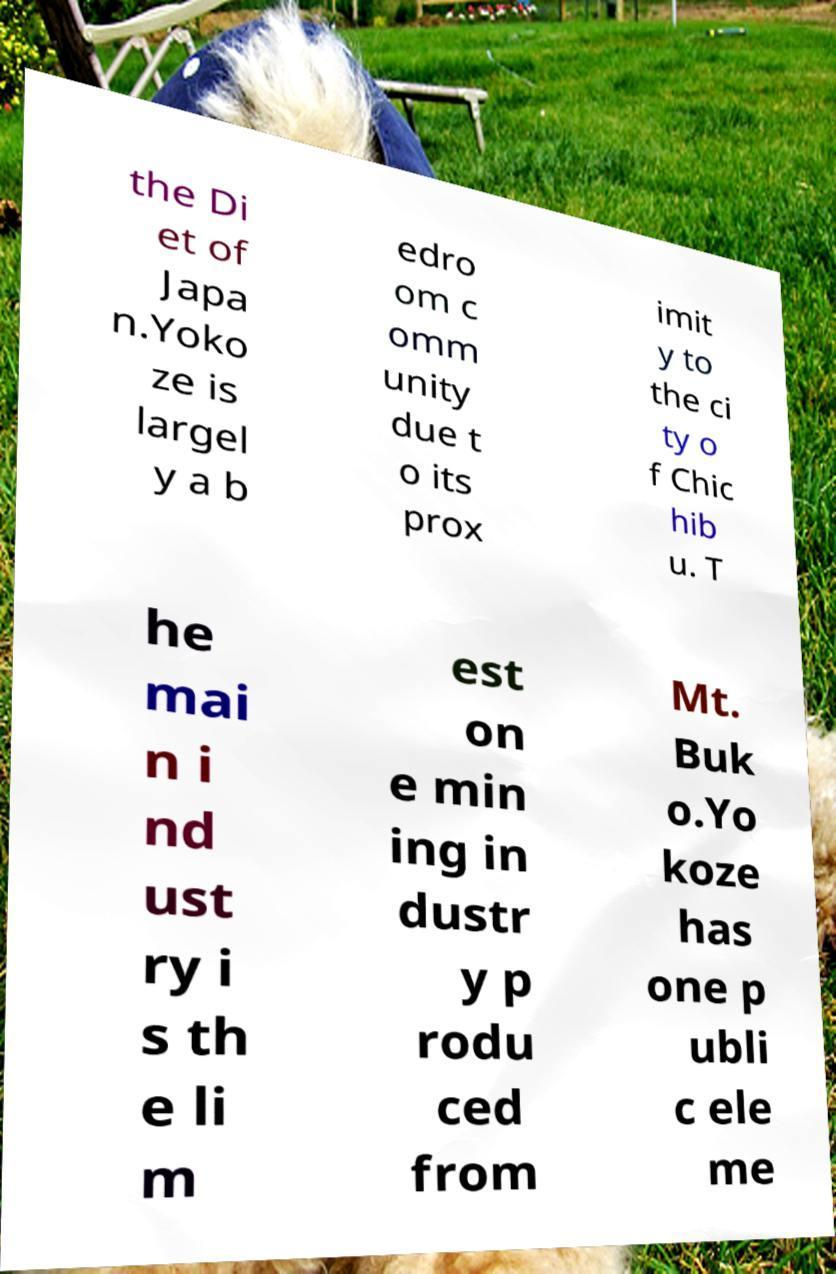Can you read and provide the text displayed in the image?This photo seems to have some interesting text. Can you extract and type it out for me? the Di et of Japa n.Yoko ze is largel y a b edro om c omm unity due t o its prox imit y to the ci ty o f Chic hib u. T he mai n i nd ust ry i s th e li m est on e min ing in dustr y p rodu ced from Mt. Buk o.Yo koze has one p ubli c ele me 